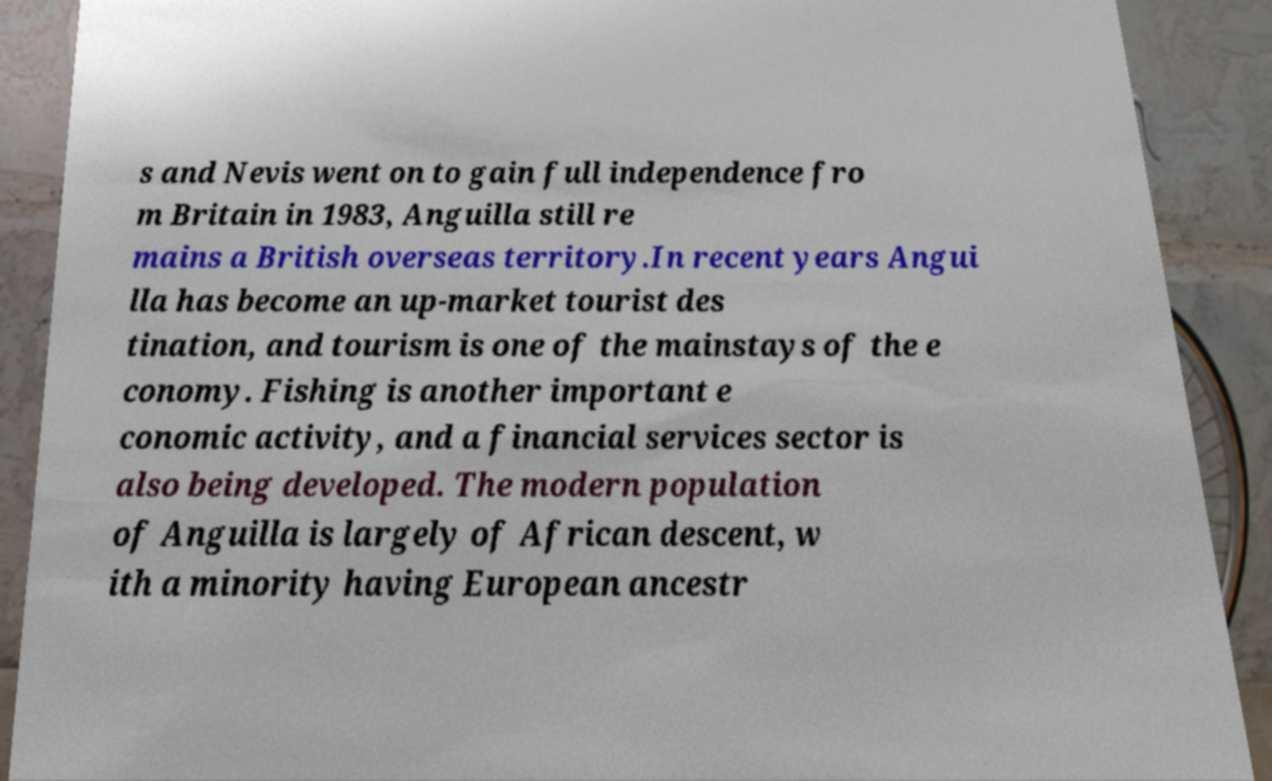Could you assist in decoding the text presented in this image and type it out clearly? s and Nevis went on to gain full independence fro m Britain in 1983, Anguilla still re mains a British overseas territory.In recent years Angui lla has become an up-market tourist des tination, and tourism is one of the mainstays of the e conomy. Fishing is another important e conomic activity, and a financial services sector is also being developed. The modern population of Anguilla is largely of African descent, w ith a minority having European ancestr 